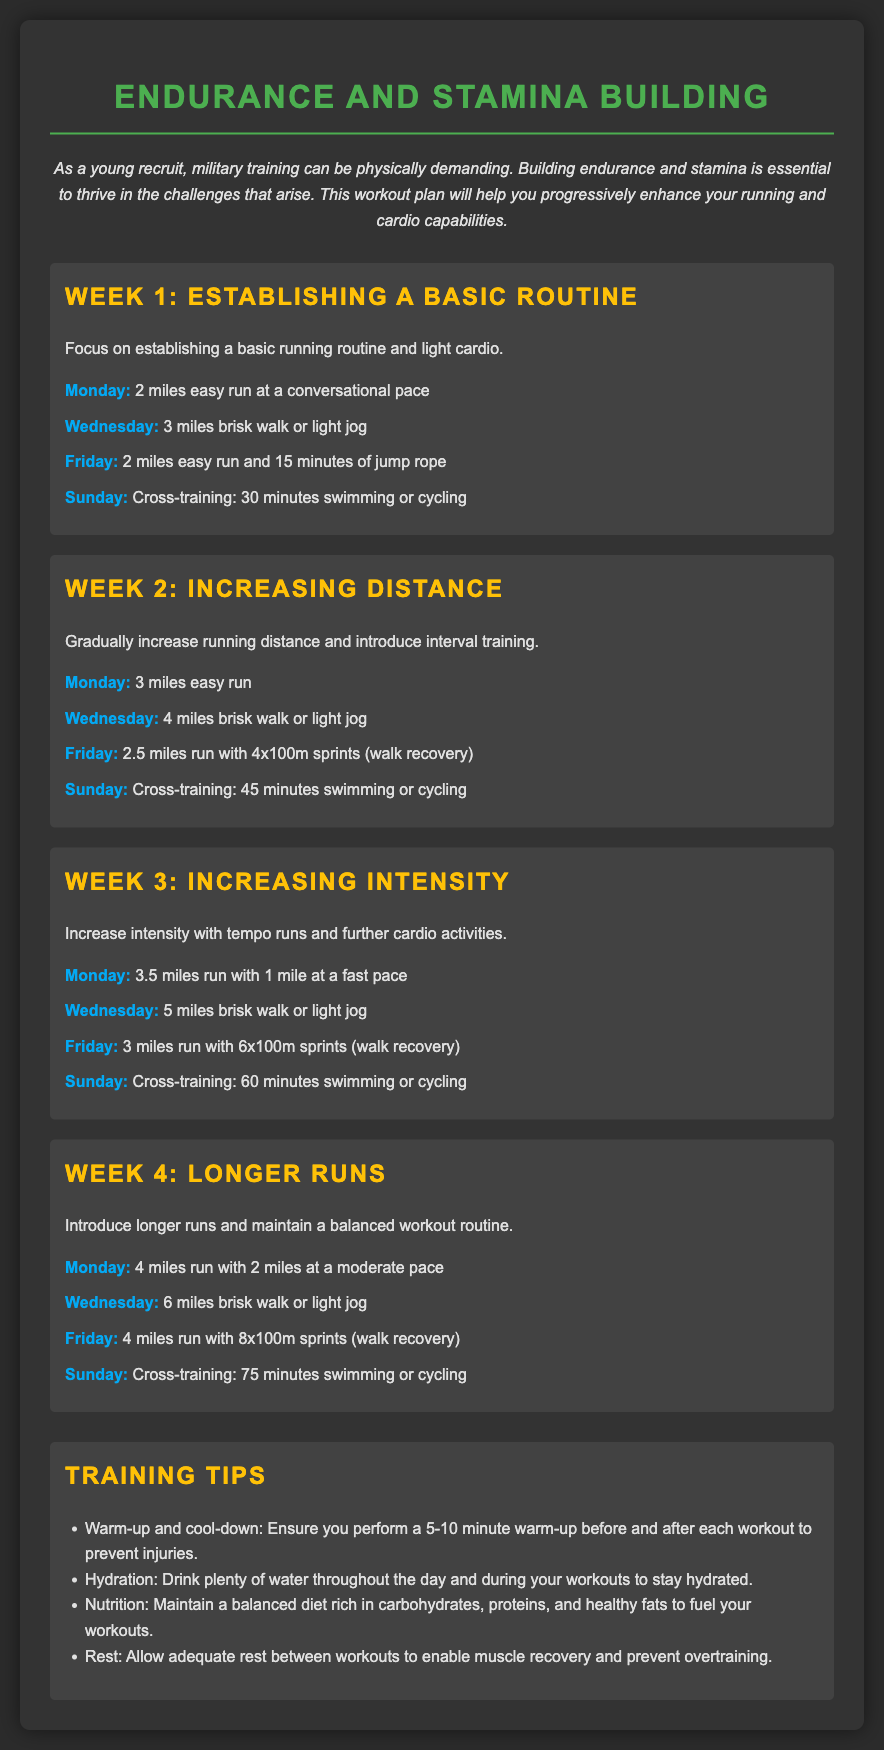What is the focus of Week 1? Week 1 focuses on establishing a basic running routine and light cardio.
Answer: establishing a basic running routine and light cardio How many miles should you run on Monday of Week 2? The document states that on Monday of Week 2, you should run 3 miles.
Answer: 3 miles What type of cross-training is suggested for Sunday of Week 4? The document suggests 75 minutes of swimming or cycling as cross-training for Sunday of Week 4.
Answer: 75 minutes swimming or cycling How many sprints are included in Week 3's Friday workout? In Week 3 on Friday, the workout includes 6x100m sprints.
Answer: 6 What is the recommended warm-up duration before workouts? The document recommends performing a 5-10 minute warm-up before workouts.
Answer: 5-10 minutes 